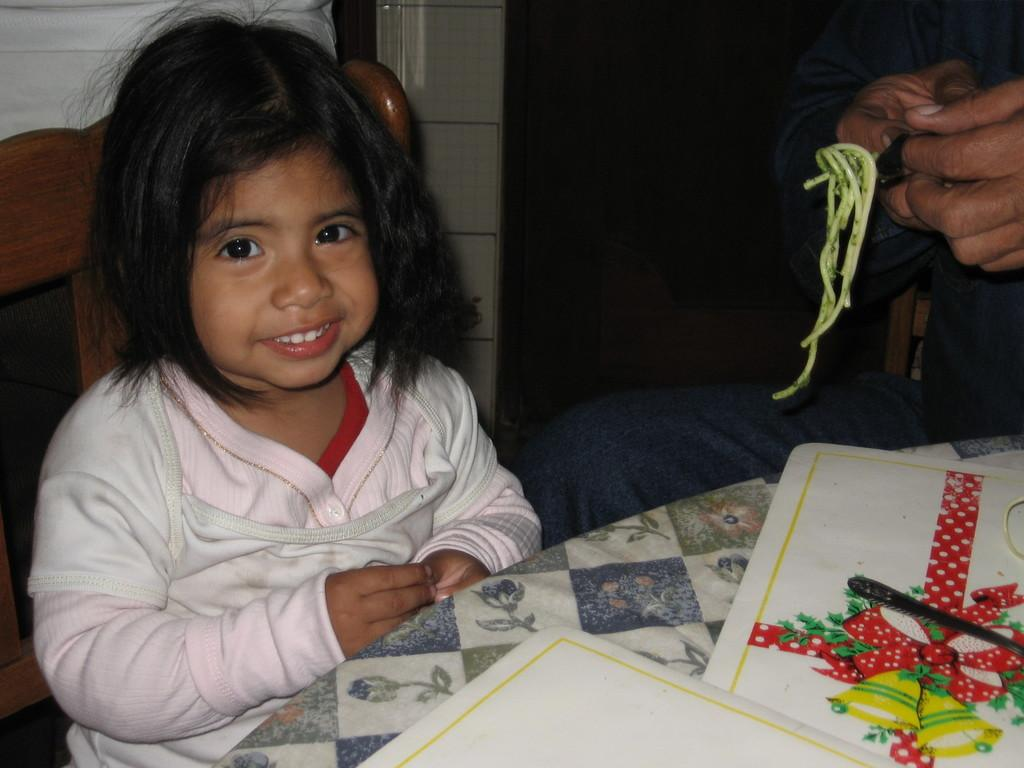What is the kid doing in the image? The kid is sitting on a chair in the image. What is the man holding in the image? The man is holding a fork in the image. What is the man holding the fork near? The man is holding a food item. What can be seen at the bottom of the image? There are papers at the bottom of the image. What utensil is present on the table in the image? There is a spoon on the table in the image. What type of jewel is the kid wearing in the image? There is no mention of a jewel in the image; the kid is simply sitting on a chair. How many horses are visible in the image? There are no horses present in the image. 